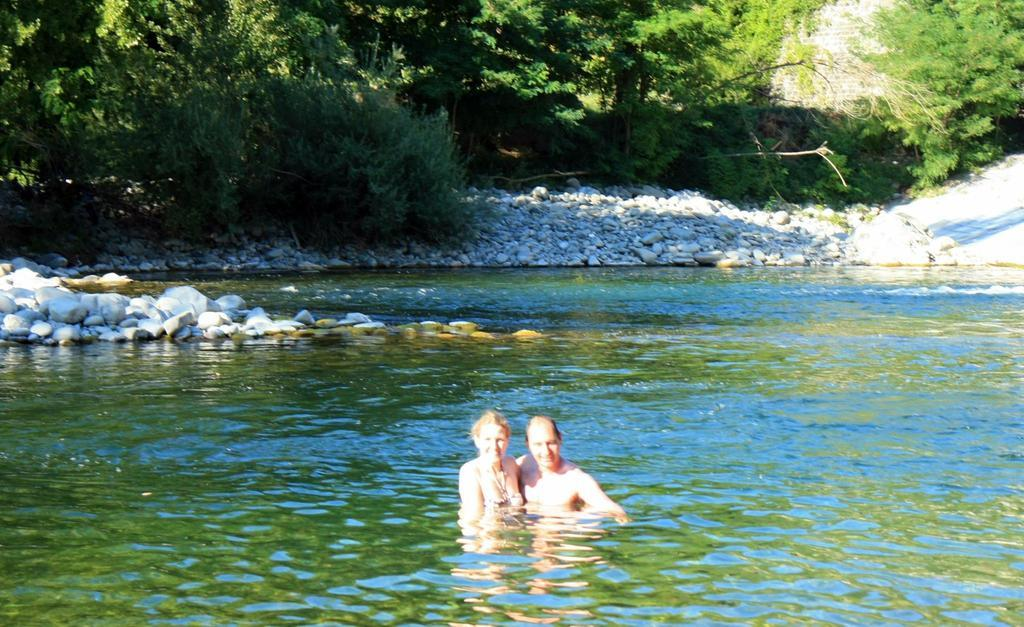Who is present in the image? There is a man and a woman in the image. What are the expressions on their faces? Both the man and the woman are smiling. Where are they located in the image? They are in the water. What other elements can be seen in the image? There are stones, plants, and trees visible in the image. What type of teeth can be seen on the scale in the image? There is no scale or teeth present in the image. 